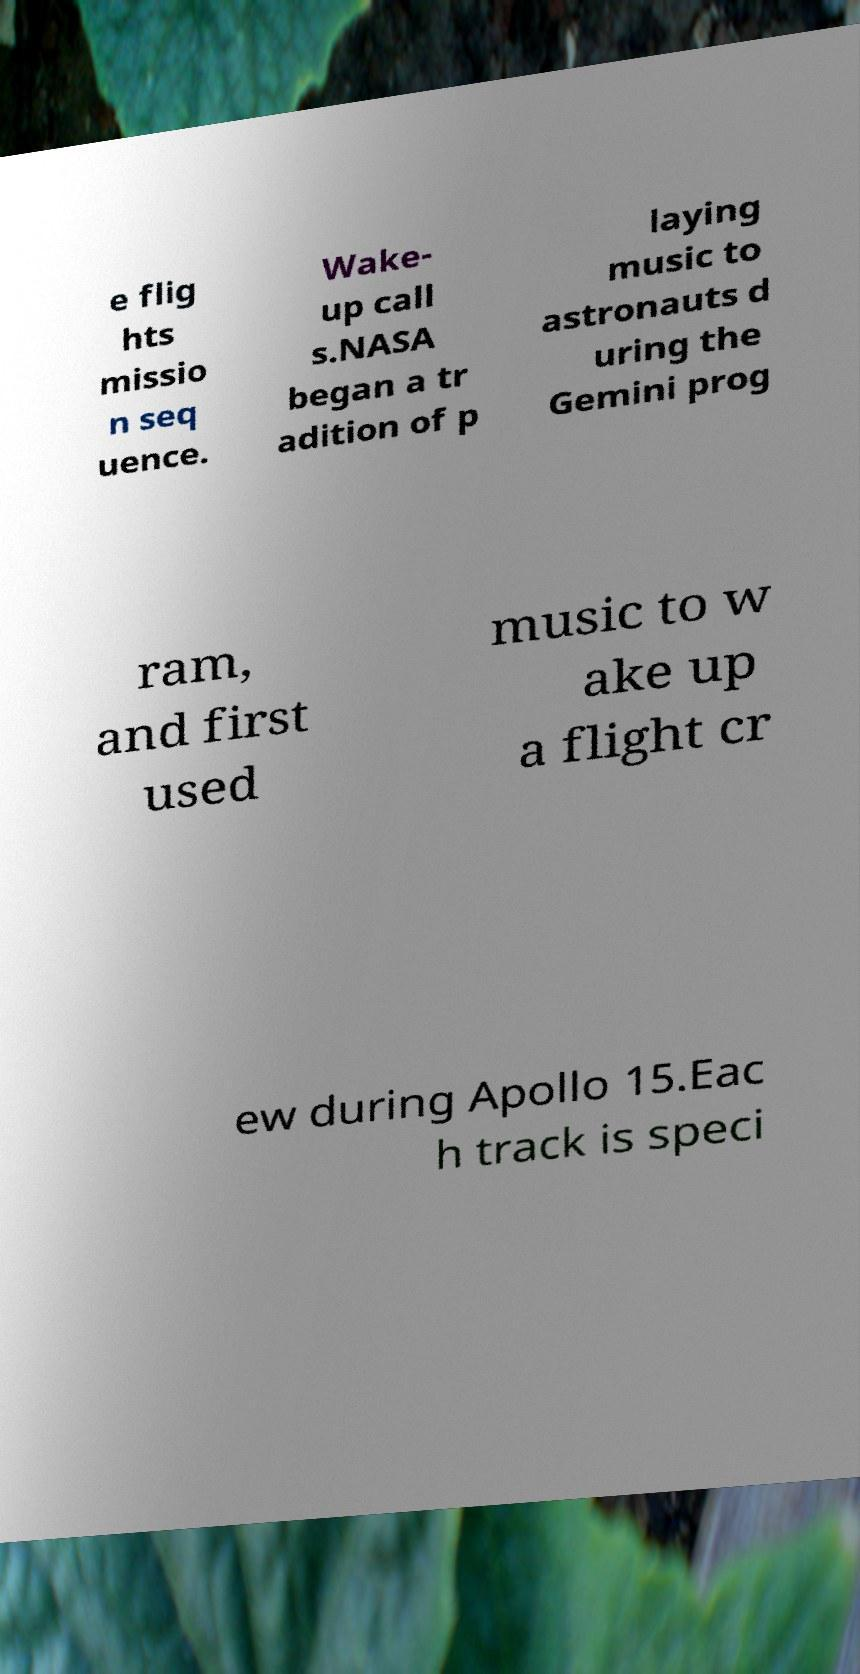For documentation purposes, I need the text within this image transcribed. Could you provide that? e flig hts missio n seq uence. Wake- up call s.NASA began a tr adition of p laying music to astronauts d uring the Gemini prog ram, and first used music to w ake up a flight cr ew during Apollo 15.Eac h track is speci 